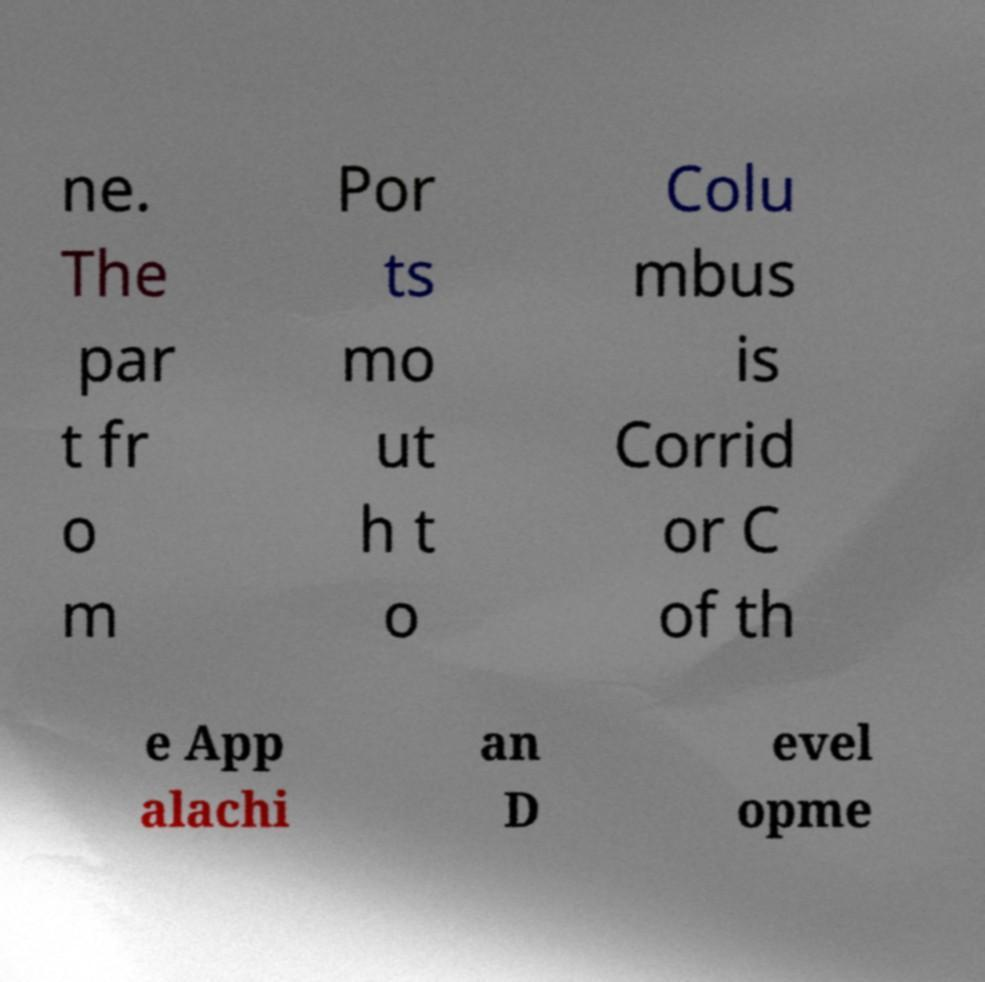Please read and relay the text visible in this image. What does it say? ne. The par t fr o m Por ts mo ut h t o Colu mbus is Corrid or C of th e App alachi an D evel opme 